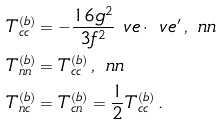<formula> <loc_0><loc_0><loc_500><loc_500>T _ { c c } ^ { ( b ) } & = - \frac { 1 6 g ^ { 2 } } { 3 f ^ { 2 } } \ v e \cdot \ v e ^ { \prime } \, , \ n n \\ T _ { n n } ^ { ( b ) } & = T _ { c c } ^ { ( b ) } \, , \ n n \\ T ^ { ( b ) } _ { n c } & = T ^ { ( b ) } _ { c n } = \frac { 1 } { 2 } T _ { c c } ^ { ( b ) } \, .</formula> 